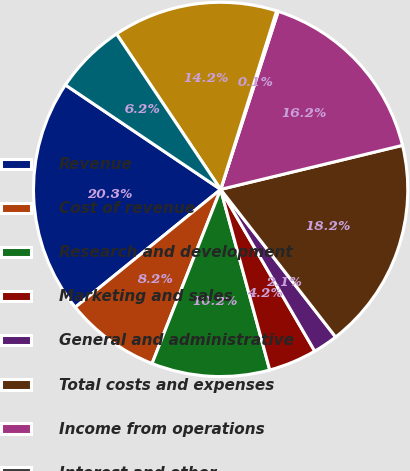Convert chart to OTSL. <chart><loc_0><loc_0><loc_500><loc_500><pie_chart><fcel>Revenue<fcel>Cost of revenue<fcel>Research and development<fcel>Marketing and sales<fcel>General and administrative<fcel>Total costs and expenses<fcel>Income from operations<fcel>Interest and other<fcel>Income before provision for<fcel>Provision for income taxes<nl><fcel>20.27%<fcel>8.19%<fcel>10.2%<fcel>4.16%<fcel>2.15%<fcel>18.25%<fcel>16.24%<fcel>0.14%<fcel>14.23%<fcel>6.18%<nl></chart> 